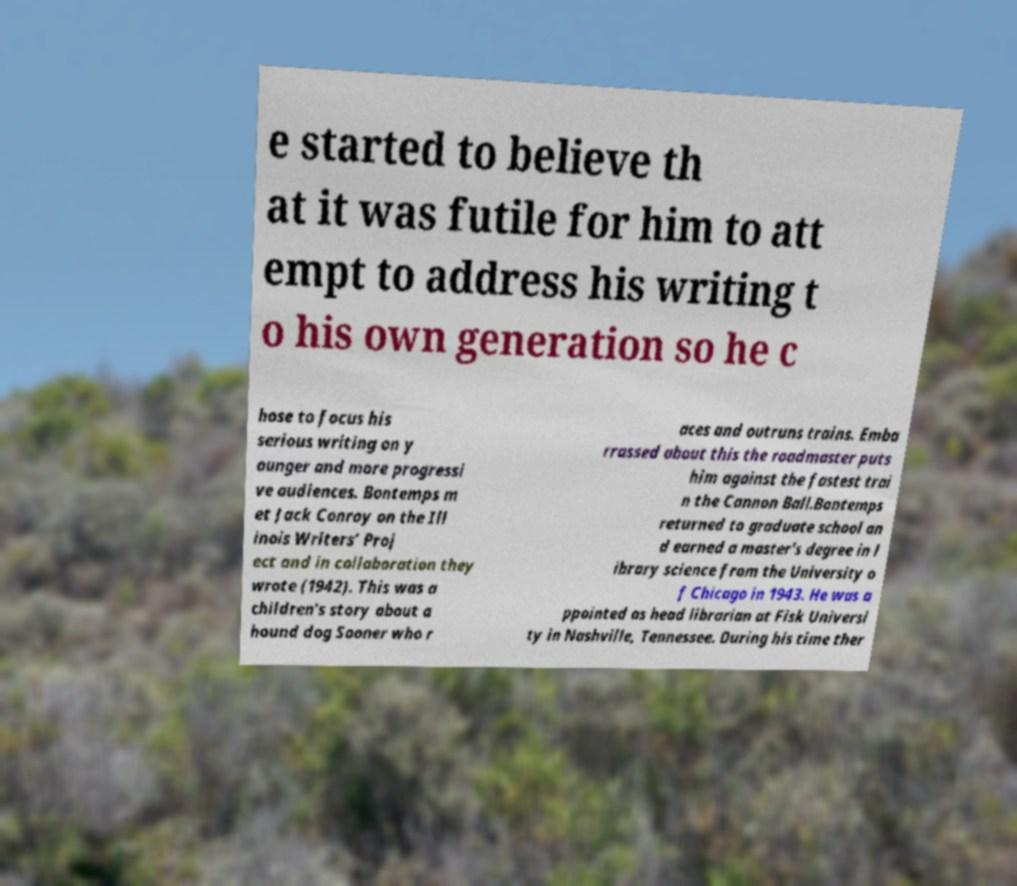Can you read and provide the text displayed in the image?This photo seems to have some interesting text. Can you extract and type it out for me? e started to believe th at it was futile for him to att empt to address his writing t o his own generation so he c hose to focus his serious writing on y ounger and more progressi ve audiences. Bontemps m et Jack Conroy on the Ill inois Writers’ Proj ect and in collaboration they wrote (1942). This was a children's story about a hound dog Sooner who r aces and outruns trains. Emba rrassed about this the roadmaster puts him against the fastest trai n the Cannon Ball.Bontemps returned to graduate school an d earned a master's degree in l ibrary science from the University o f Chicago in 1943. He was a ppointed as head librarian at Fisk Universi ty in Nashville, Tennessee. During his time ther 